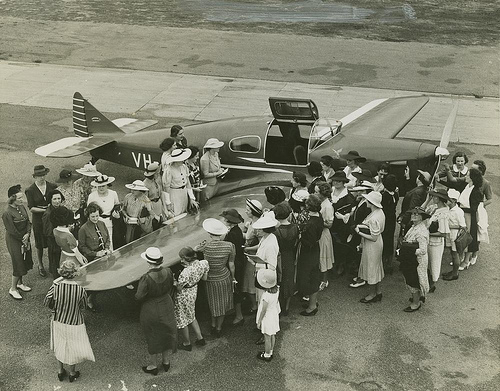Can you describe the activity taking place around the airplane? Certainly! It appears to be a social event or gathering where the attendees are showing great interest in the airplane, possibly during an exhibition or public demonstration. 